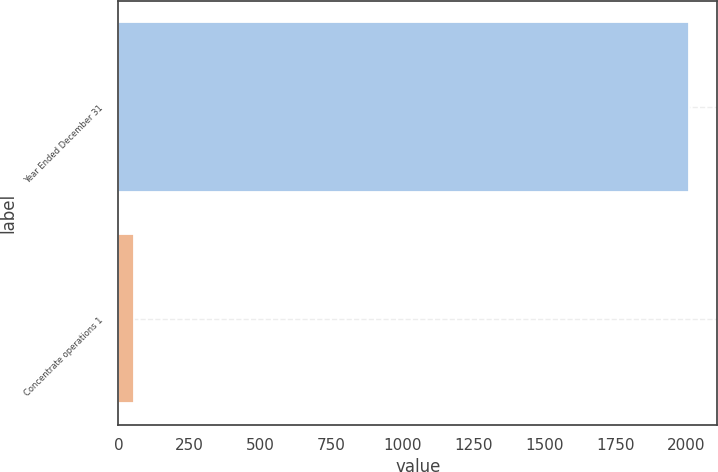Convert chart to OTSL. <chart><loc_0><loc_0><loc_500><loc_500><bar_chart><fcel>Year Ended December 31<fcel>Concentrate operations 1<nl><fcel>2009<fcel>54<nl></chart> 